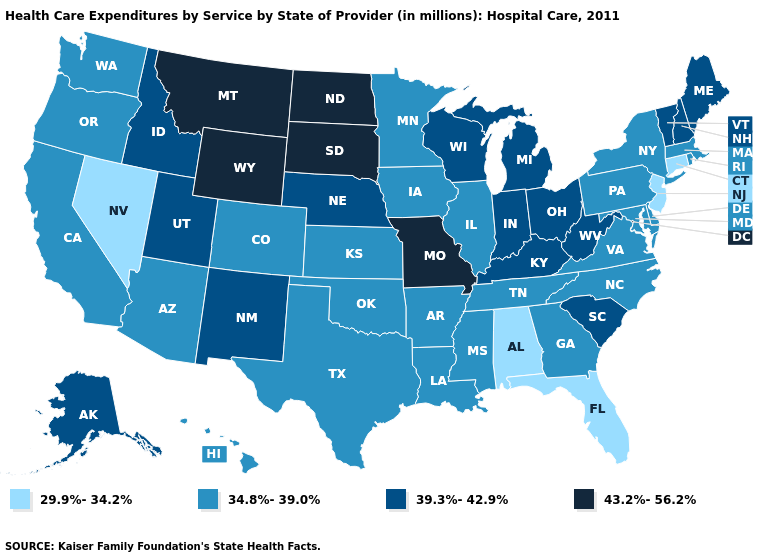What is the lowest value in the MidWest?
Be succinct. 34.8%-39.0%. What is the highest value in states that border South Carolina?
Give a very brief answer. 34.8%-39.0%. Does the first symbol in the legend represent the smallest category?
Quick response, please. Yes. Does the map have missing data?
Write a very short answer. No. Does Alabama have the lowest value in the USA?
Write a very short answer. Yes. What is the lowest value in states that border Illinois?
Concise answer only. 34.8%-39.0%. What is the value of Pennsylvania?
Short answer required. 34.8%-39.0%. Is the legend a continuous bar?
Short answer required. No. What is the highest value in the Northeast ?
Write a very short answer. 39.3%-42.9%. Is the legend a continuous bar?
Short answer required. No. Among the states that border Delaware , does Pennsylvania have the lowest value?
Short answer required. No. Which states have the highest value in the USA?
Write a very short answer. Missouri, Montana, North Dakota, South Dakota, Wyoming. Does Texas have a lower value than Tennessee?
Answer briefly. No. How many symbols are there in the legend?
Quick response, please. 4. What is the value of Florida?
Concise answer only. 29.9%-34.2%. 